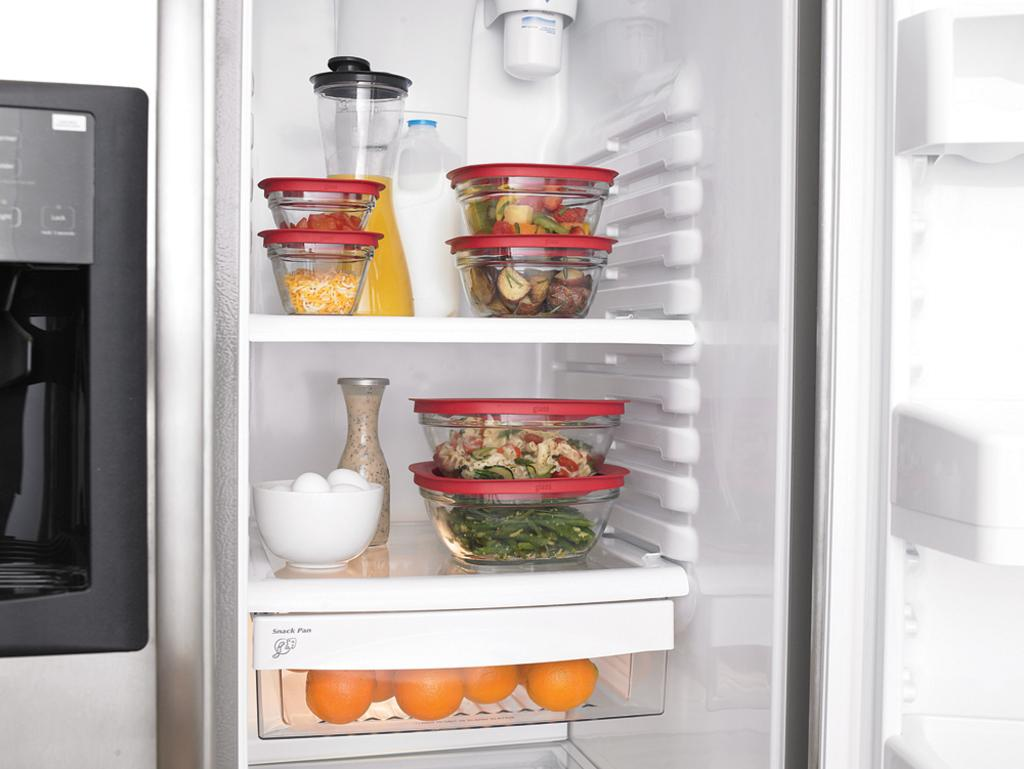What type of appliance is present in the image? There is a fridge in the image. What can be found inside the fridge? There are food items in the fridge. Can you tell me how many goose eggs are visible in the image? There are no goose eggs present in the image. Who is the creator of the fridge in the image? The creator of the fridge is not visible or identifiable in the image. 